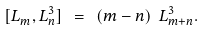<formula> <loc_0><loc_0><loc_500><loc_500>[ L ^ { \ } _ { m } , L ^ { 3 } _ { n } ] \ = \ ( m - n ) \ L ^ { 3 } _ { m + n } .</formula> 